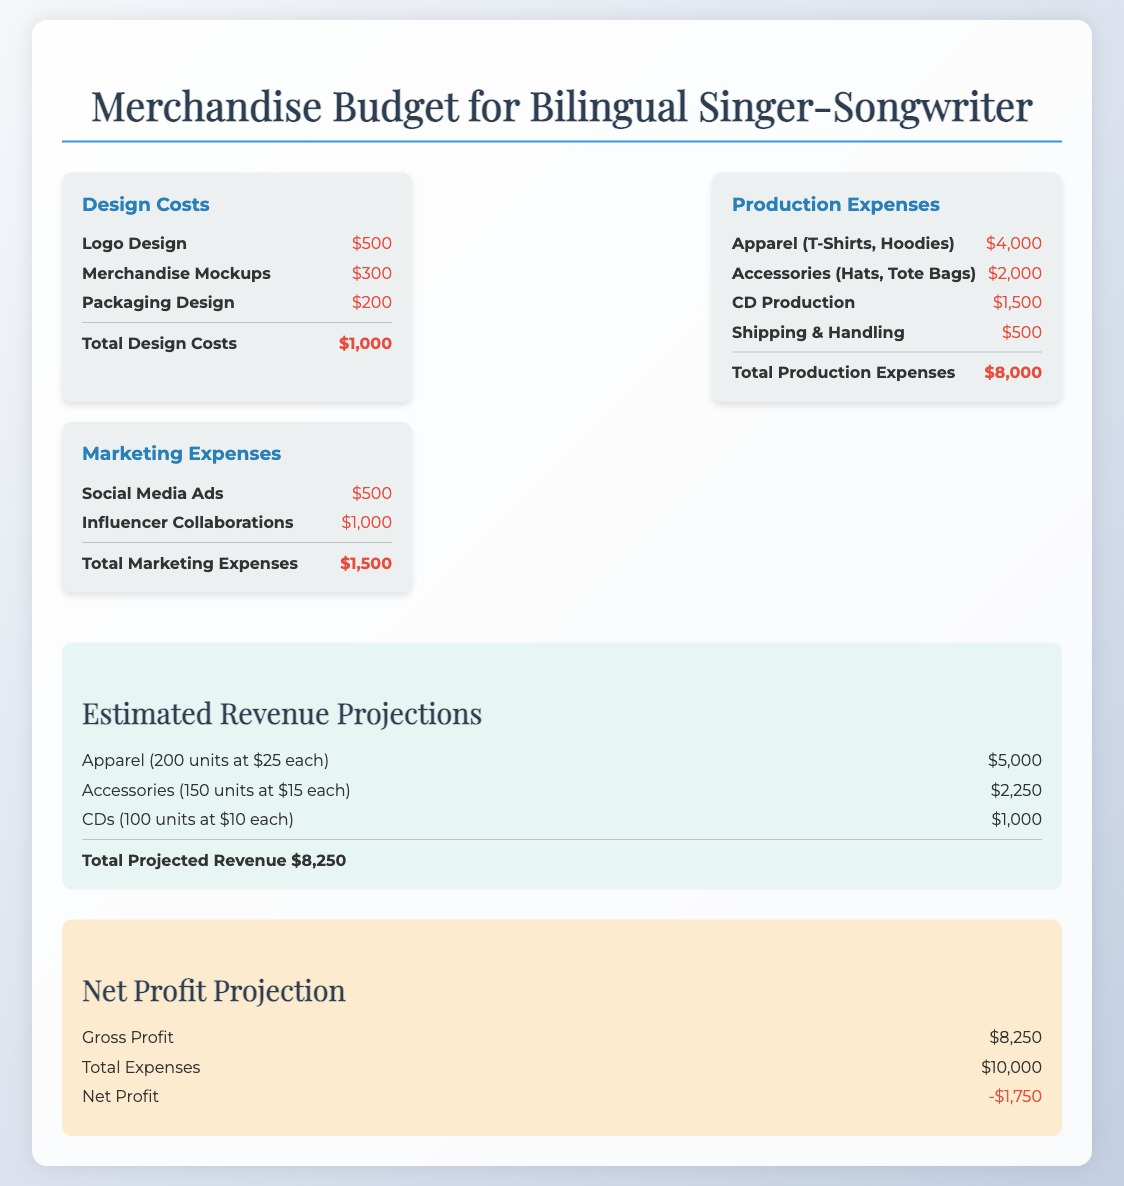What is the total design cost? The total design cost is listed under the design costs section of the document, which adds up to $1,000.
Answer: $1,000 What is the revenue from apparel? The revenue from apparel is calculated based on 200 units sold at $25 each, which totals $5,000.
Answer: $5,000 What is the total production expense? The total production expense is the sum of all production-related items, which amounts to $8,000.
Answer: $8,000 What is the net profit? The net profit is calculated as the difference between the gross profit and total expenses, resulting in -$1,750.
Answer: -$1,750 How much is allocated for shipping and handling? The shipping and handling cost is detailed under production expenses, which amounts to $500.
Answer: $500 What percentage of the total expenses is marketing expenses? The marketing expenses total $1,500 out of total expenses of $10,000, which is 15%.
Answer: 15% What is the cost of accessories? The cost of accessories is listed as $2,000 under production expenses.
Answer: $2,000 How many CDs are projected to be sold? The document states that 100 units of CDs are projected to be sold.
Answer: 100 units 